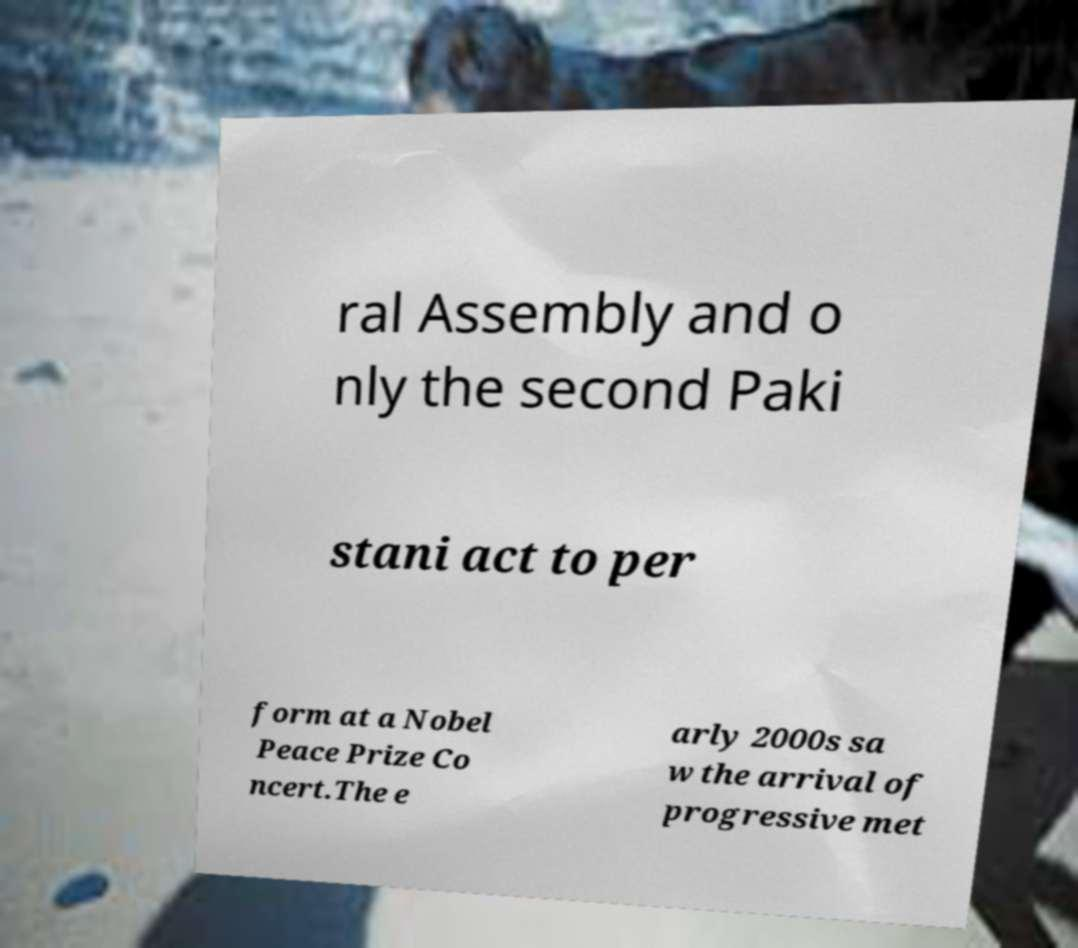For documentation purposes, I need the text within this image transcribed. Could you provide that? ral Assembly and o nly the second Paki stani act to per form at a Nobel Peace Prize Co ncert.The e arly 2000s sa w the arrival of progressive met 